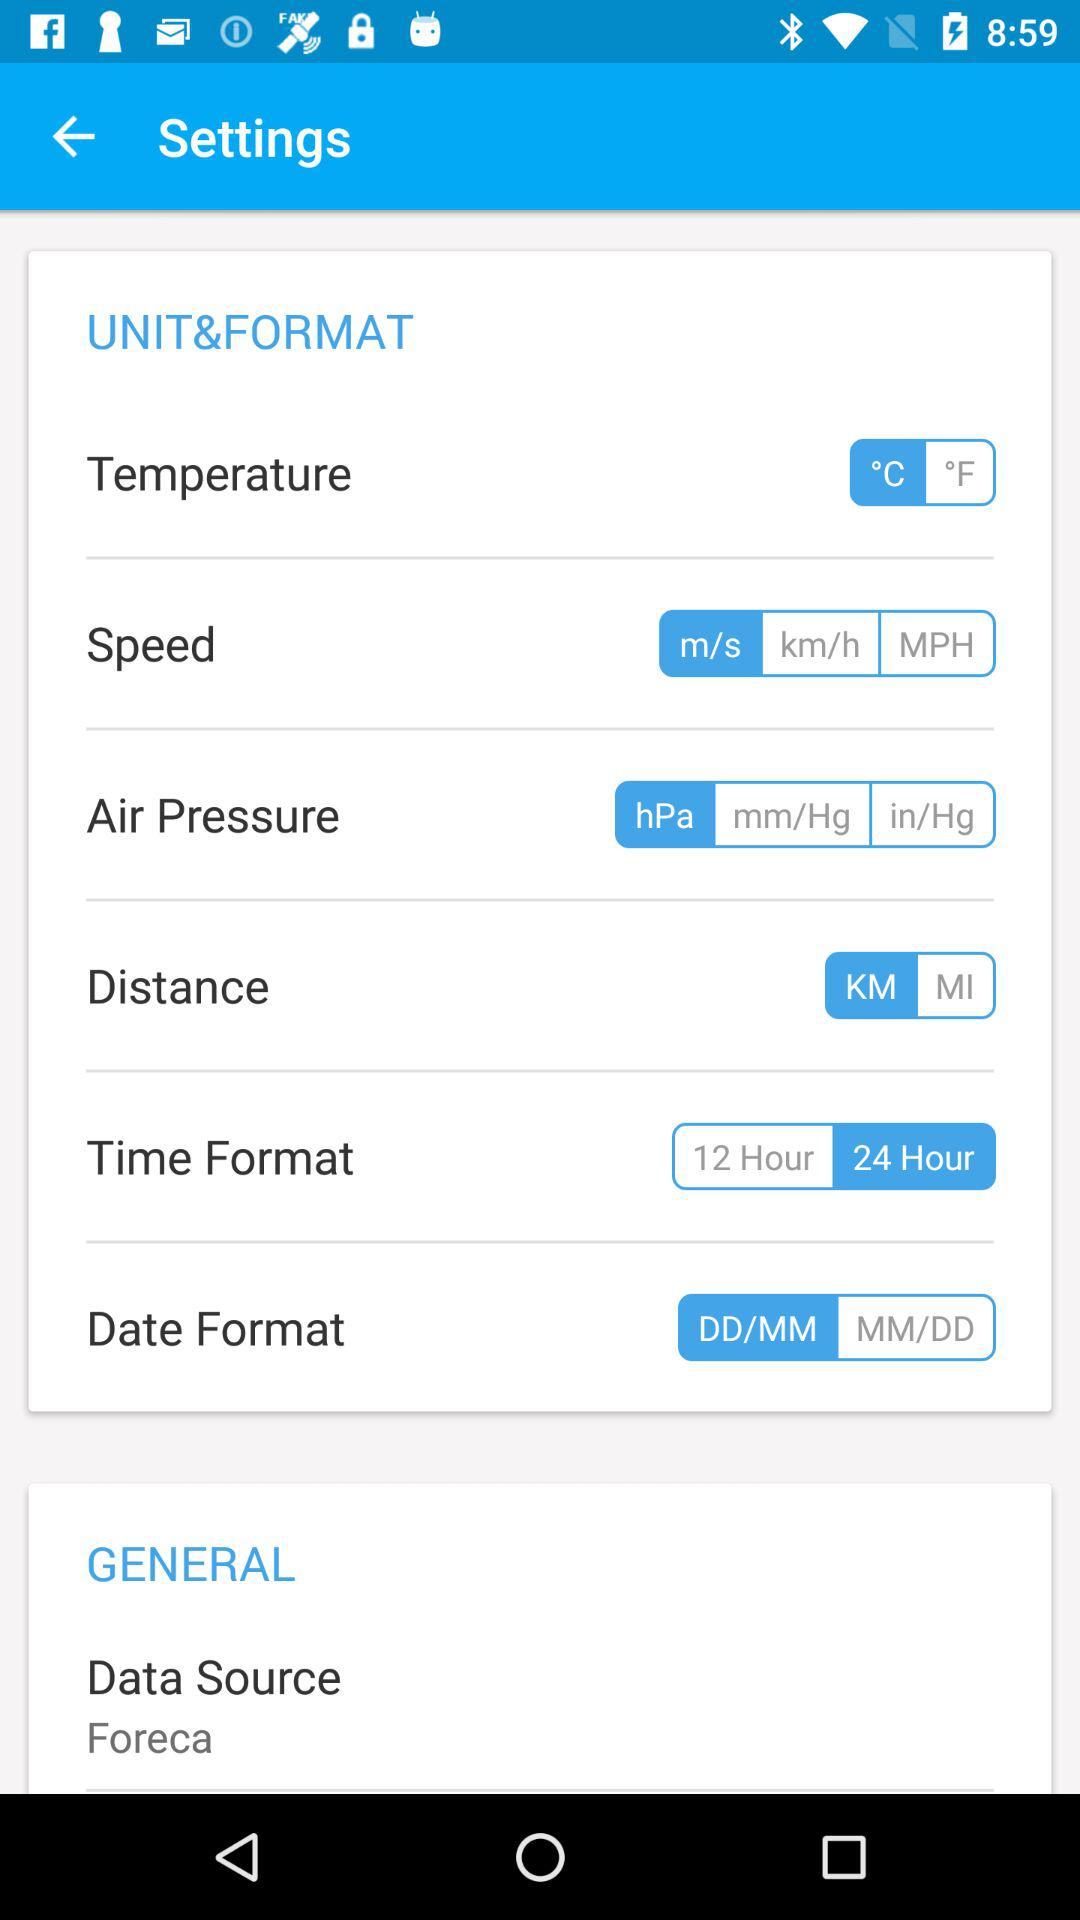Which unit of speed is selected? The selected unit of speed is m/s. 